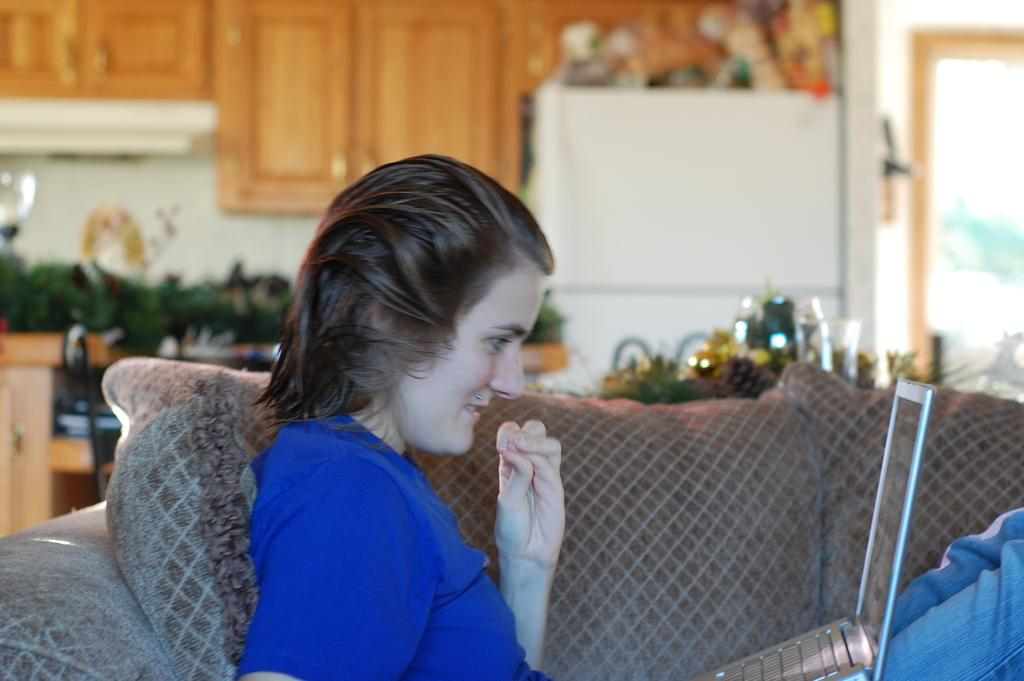Who is the main subject in the image? There is a girl in the image. What is the girl doing in the image? The girl is sitting on a sofa. What is the girl holding or using in the image? The girl has a laptop on her lap. What can be seen behind the girl in the image? There are cupboards visible behind the girl, as well as other unspecified objects. What type of silk fabric is draped over the girl's shoulder in the image? There is no silk fabric visible on the girl's shoulder in the image. 